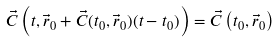<formula> <loc_0><loc_0><loc_500><loc_500>\vec { C } \left ( t , \vec { r } _ { 0 } + \vec { C } ( t _ { 0 } , \vec { r } _ { 0 } ) ( t - t _ { 0 } ) \right ) = \vec { C } \left ( t _ { 0 } , \vec { r } _ { 0 } \right )</formula> 